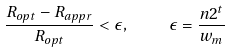<formula> <loc_0><loc_0><loc_500><loc_500>\frac { R _ { o p t } - R _ { a p p r } } { R _ { o p t } } < \epsilon , \quad \epsilon = \frac { n 2 ^ { t } } { w _ { m } }</formula> 